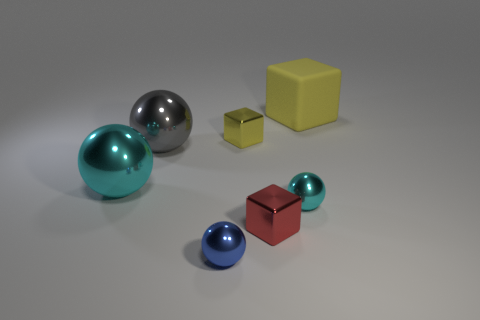Are there any other things that are the same material as the big cube?
Give a very brief answer. No. Is the big gray sphere made of the same material as the cyan object in front of the large cyan metal thing?
Your answer should be compact. Yes. Is the number of small cyan things that are right of the small red metallic thing less than the number of big matte blocks on the left side of the big gray sphere?
Keep it short and to the point. No. There is a cyan sphere on the left side of the blue metal sphere; what is its material?
Your response must be concise. Metal. What color is the tiny object that is behind the tiny red thing and left of the small red object?
Your response must be concise. Yellow. How many other things are there of the same color as the rubber object?
Ensure brevity in your answer.  1. What is the color of the big object that is on the right side of the small blue thing?
Keep it short and to the point. Yellow. Are there any blue spheres of the same size as the red thing?
Offer a terse response. Yes. What is the material of the yellow cube that is the same size as the blue thing?
Offer a very short reply. Metal. What number of objects are either objects that are on the left side of the small red cube or metal objects that are on the left side of the small blue ball?
Make the answer very short. 4. 